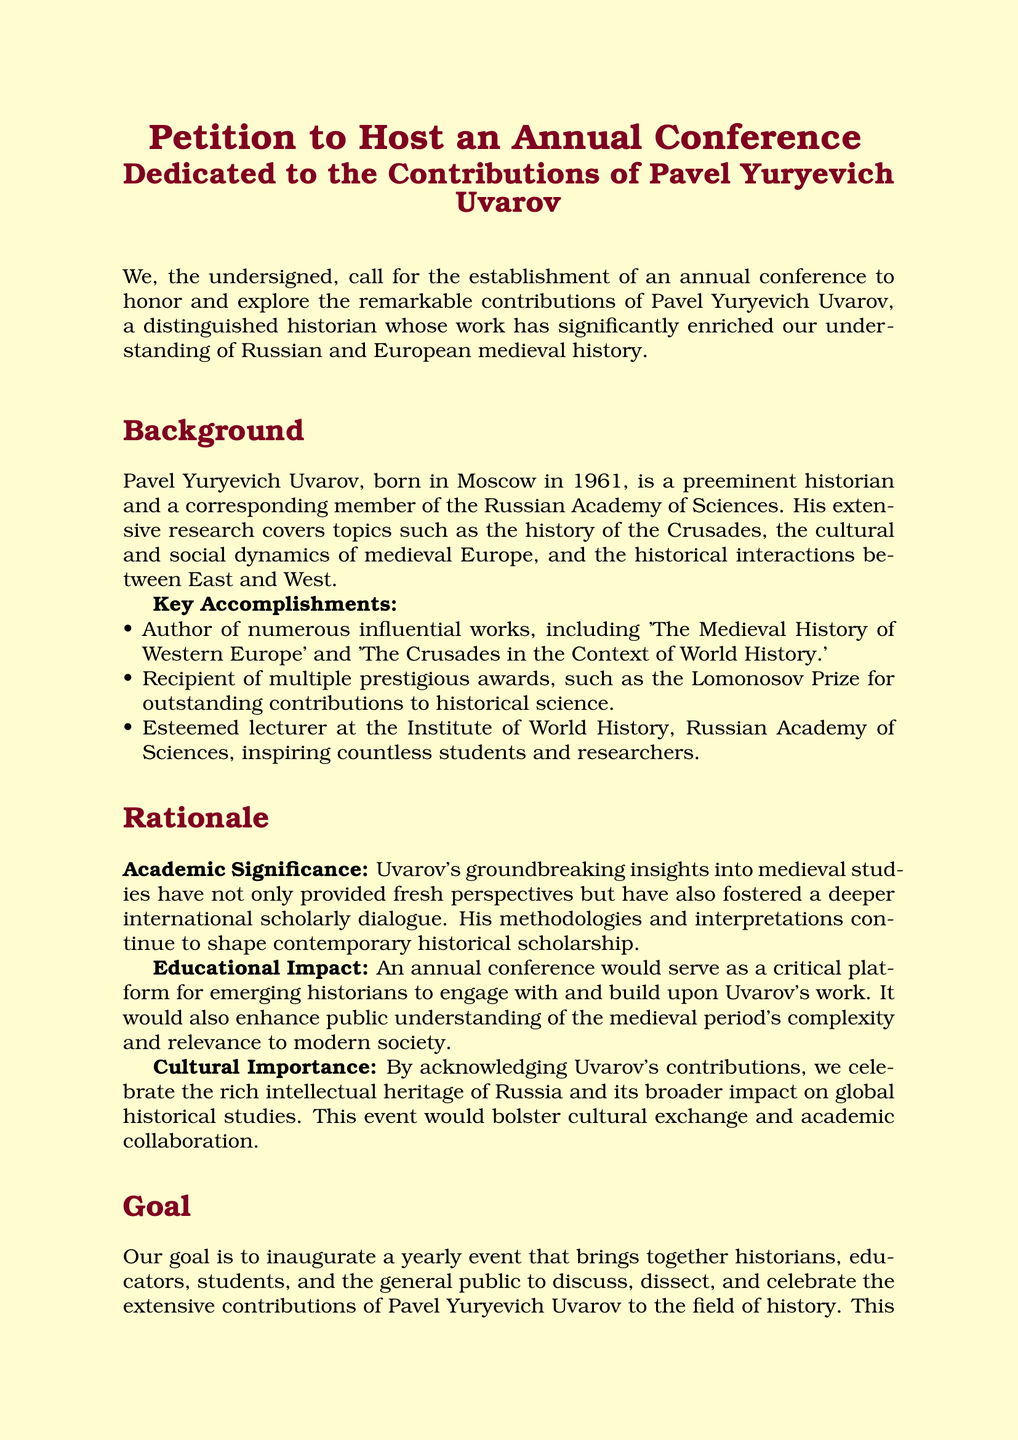What is the purpose of the petition? The petition calls for the establishment of an annual conference to honor and explore the contributions of Pavel Yuryevich Uvarov.
Answer: To establish an annual conference Who is Pavel Yuryevich Uvarov? Pavel Yuryevich Uvarov is a distinguished historian and corresponding member of the Russian Academy of Sciences.
Answer: A distinguished historian What is one of Uvarov's key accomplishments? Uvarov is the author of 'The Medieval History of Western Europe'.
Answer: Author of 'The Medieval History of Western Europe' What award did Uvarov receive for his contributions? Uvarov received the Lomonosov Prize for outstanding contributions to historical science.
Answer: Lomonosov Prize In what year was Pavel Uvarov born? Pavel Uvarov was born in 1961.
Answer: 1961 What is one academic significance of Uvarov's work? His insights fostered a deeper international scholarly dialogue in medieval studies.
Answer: Deeper international scholarly dialogue What does the petition urge supporters to do? The petition urges academic institutions, cultural organizations, and individual supporters to join in endorsing the petition.
Answer: Endorsing the petition What is the goal of the proposed conference? The goal is to bring together historians, educators, students, and the public to celebrate Uvarov's contributions to history.
Answer: To celebrate Uvarov's contributions 